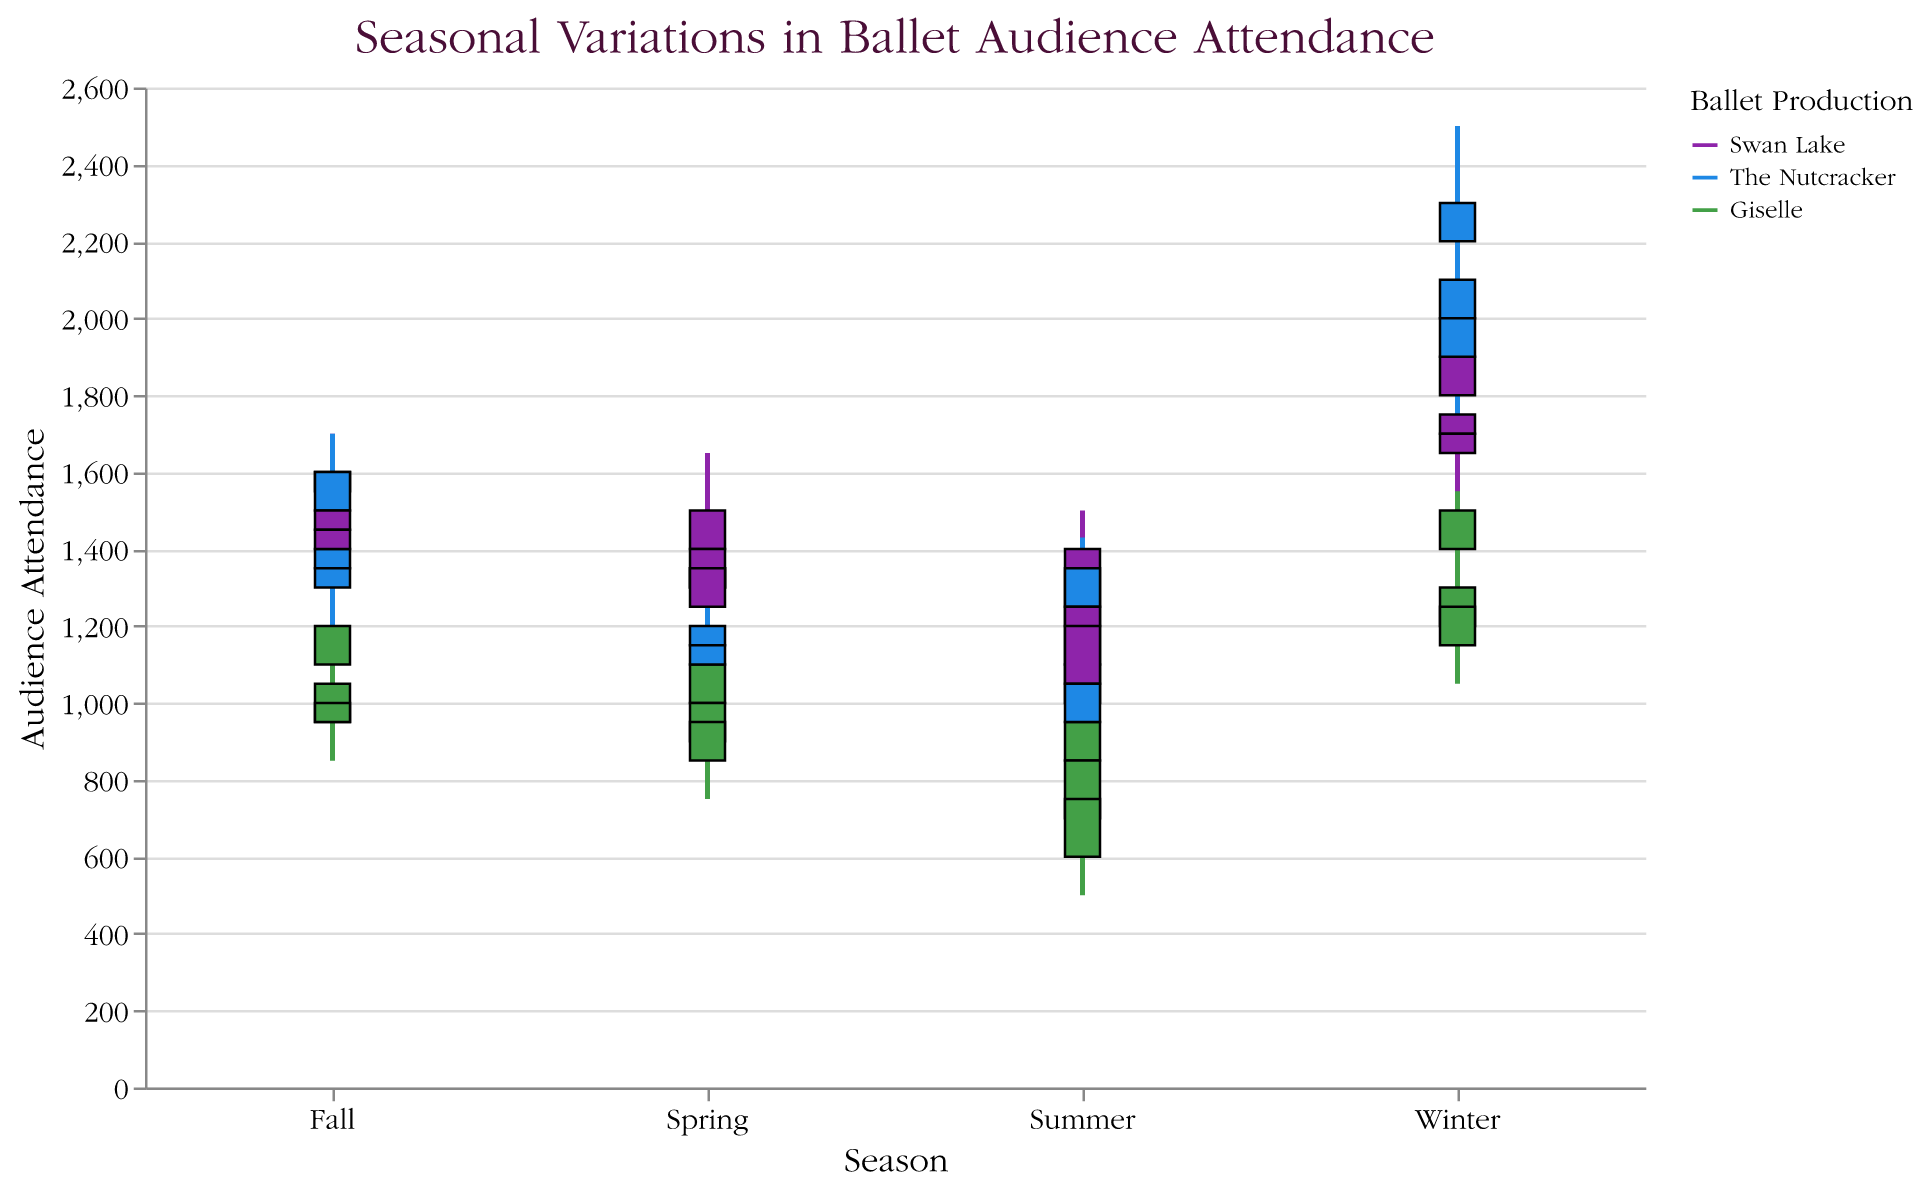Which city shows the highest winter attendance for "The Nutcracker"? In the plot, locate "The Nutcracker" in the winter columns and observe the highest "Close" values. New York has a "Close" value of 2300, which is the highest.
Answer: New York What is the difference in summer attendance between "Swan Lake" and "Giselle" in Paris? Identify the "Close" values for "Swan Lake" and "Giselle" in Paris during summer (1200 for "Swan Lake" and 750 for "Giselle"), then find the difference: 1200 - 750 = 450.
Answer: 450 Which production has the smallest range of audience attendance in New York during fall? For New York in the fall, compare the "High" and "Low" values for each production. "The Nutcracker" has the smallest range: 1700 - 1400 = 300.
Answer: The Nutcracker How does the winter attendance for "Giselle" in London compare to New York? Compare the "Close" values for "Giselle" in winter for both cities. London has 1300 and New York has 1500. New York's attendance is higher.
Answer: New York has higher attendance What is the median attendance value for "Swan Lake" in Paris throughout the year? For "Swan Lake" in Paris, arrange the "Close" values (1350, 1200, 1450, 1700) and find the median. The median is the average of the second and third values: (1350 + 1450) / 2 = 1400.
Answer: 1400 Which production in London shows a significant increase in attendance during winter compared to other seasons? Look at the winter "Close" values and compare them to other seasons for each production. "The Nutcracker" has a significant increase with a "Close" value of 2100, compared to other seasons.
Answer: The Nutcracker What is the average spring attendance for all productions in New York? Calculate the "Close" values for spring in New York and find the average: (1500 + 1350 + 1100) / 3 = 1316.67.
Answer: 1316.67 Does "Giselle" show consistent growth in attendance from spring to winter in any city? Check the "Close" values for "Giselle" from spring to winter for each city. In New York, "Giselle" shows growth from 1100 to 1500.
Answer: Yes, in New York 